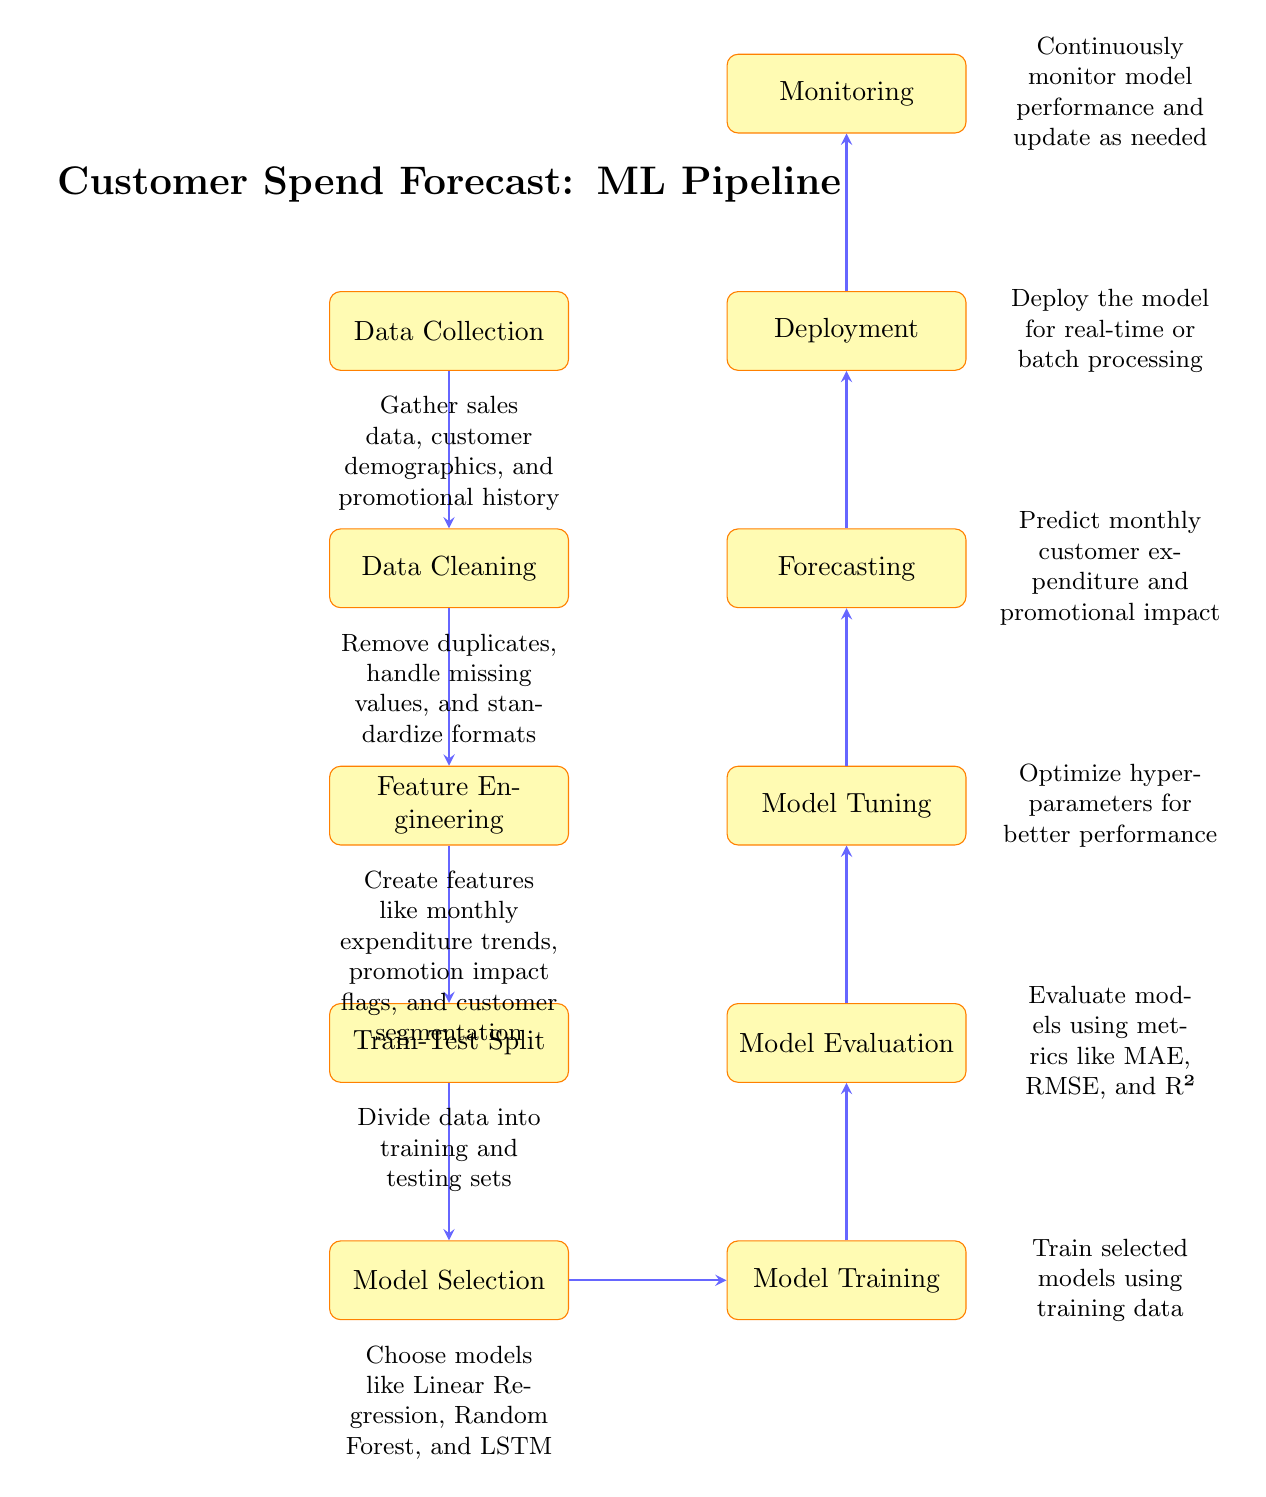What is the first step in the machine learning pipeline? The diagram indicates that the first step in the machine learning pipeline is "Data Collection." It is shown at the top of the diagram and leads to the next process.
Answer: Data Collection How many processes are included in the pipeline? By counting the processes listed vertically in the diagram, there are a total of 10 distinct processes represented from "Data Collection" to "Monitoring."
Answer: 10 What are the last two steps of the diagram? The last two steps, which are the final processes in the pipeline, are "Deployment" followed by "Monitoring." This can be seen in the upward progression of the diagram.
Answer: Deployment, Monitoring What relationship exists between "Model Training" and "Model Evaluation"? The diagram shows a direct upward arrow connecting "Model Training" to "Model Evaluation," indicating that model evaluation follows model training in the process.
Answer: Model Evaluation follows Model Training Which step involves creating new data features? The diagram specifies that the "Feature Engineering" step is responsible for creating new data features. It is situated immediately after "Data Cleaning" in the pipeline.
Answer: Feature Engineering What model selection methods are suggested in the process? According to the “Model Selection” node in the diagram, suggested methods include Linear Regression, Random Forest, and LSTM, which are explicitly mentioned within the node description.
Answer: Linear Regression, Random Forest, LSTM What happens after the "Model Tuning" phase? The diagram illustrates that after "Model Tuning," the next step in the process is "Forecasting," indicating that tuned models are then used to make predictions.
Answer: Forecasting How is the effectiveness of the model judged? "Model Evaluation" is the step where effectiveness is judged, utilizing metrics such as MAE, RMSE, and R², as indicated in its description in the diagram.
Answer: Model Evaluation What is the main purpose of the "Monitoring" step? The purpose of the "Monitoring" step is to continuously assess model performance and make updates as necessary, ensuring the model remains effective over time.
Answer: Continuous performance assessment 